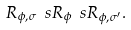Convert formula to latex. <formula><loc_0><loc_0><loc_500><loc_500>R _ { \phi , \sigma } \ s R _ { \phi } \ s R _ { \phi , \sigma ^ { \prime } } .</formula> 